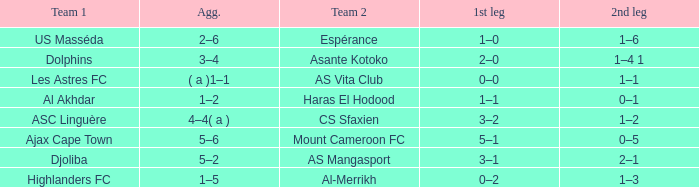What is the 2nd leg of team 1 Dolphins? 1–4 1. 